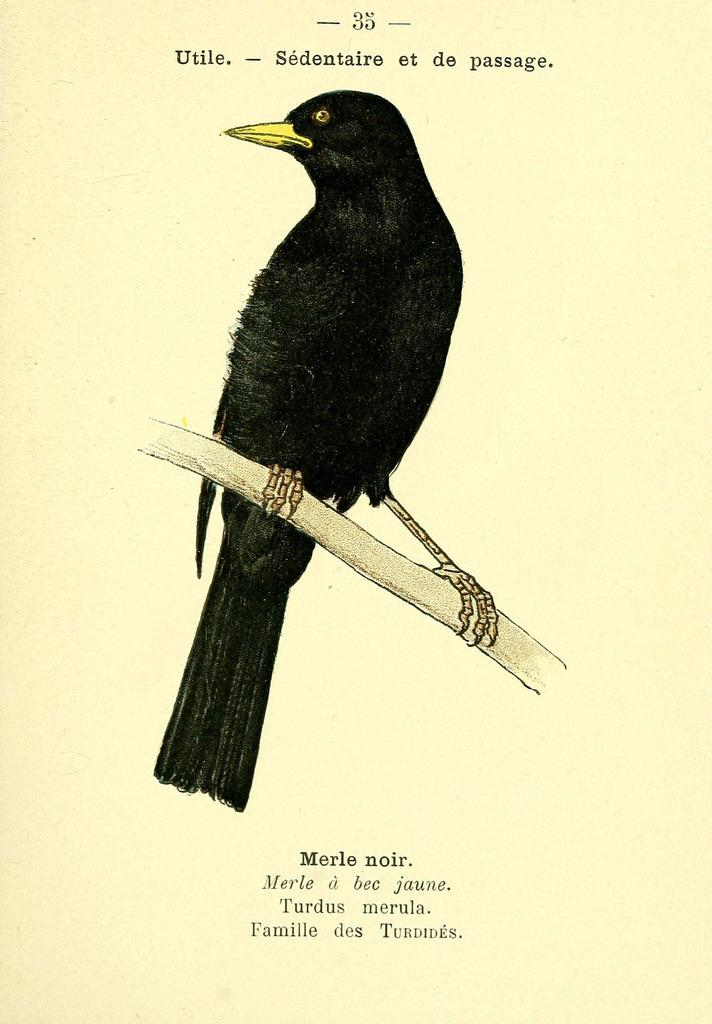What is depicted on the stem in the image? There is a picture of a bird on the stem in the image. What material is the picture printed on? The picture is printed on paper. What can be seen at the top of the image? There is text at the top of the image. What can be seen at the bottom of the image? There is text at the bottom of the image. What type of badge is the cow wearing in the image? There is no cow or badge present in the image; it features a picture of a bird on the stem with text at the top and bottom. What achievement is the achiever celebrating in the image? There is no achiever present in the image; it features a picture of a bird on the stem with text at the top and bottom. 